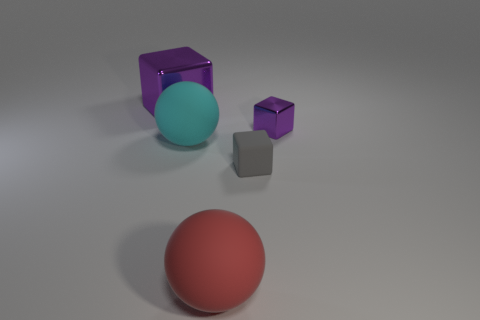Add 2 purple shiny cubes. How many objects exist? 7 Subtract all cubes. How many objects are left? 2 Subtract 1 red spheres. How many objects are left? 4 Subtract all tiny gray cubes. Subtract all large red matte balls. How many objects are left? 3 Add 4 spheres. How many spheres are left? 6 Add 4 big metallic blocks. How many big metallic blocks exist? 5 